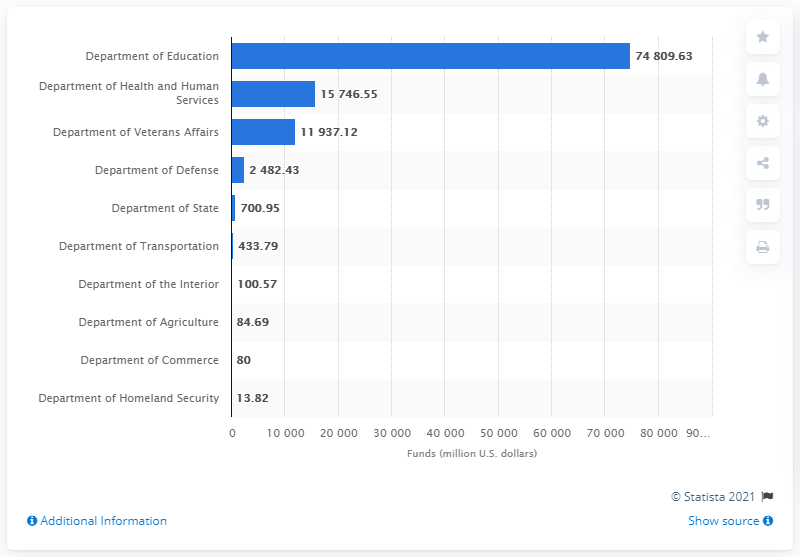Point out several critical features in this image. In 2019, the Department of Homeland Security provided a total of $13.82 million in funding to postsecondary education programs in the United States. 